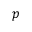Convert formula to latex. <formula><loc_0><loc_0><loc_500><loc_500>p</formula> 